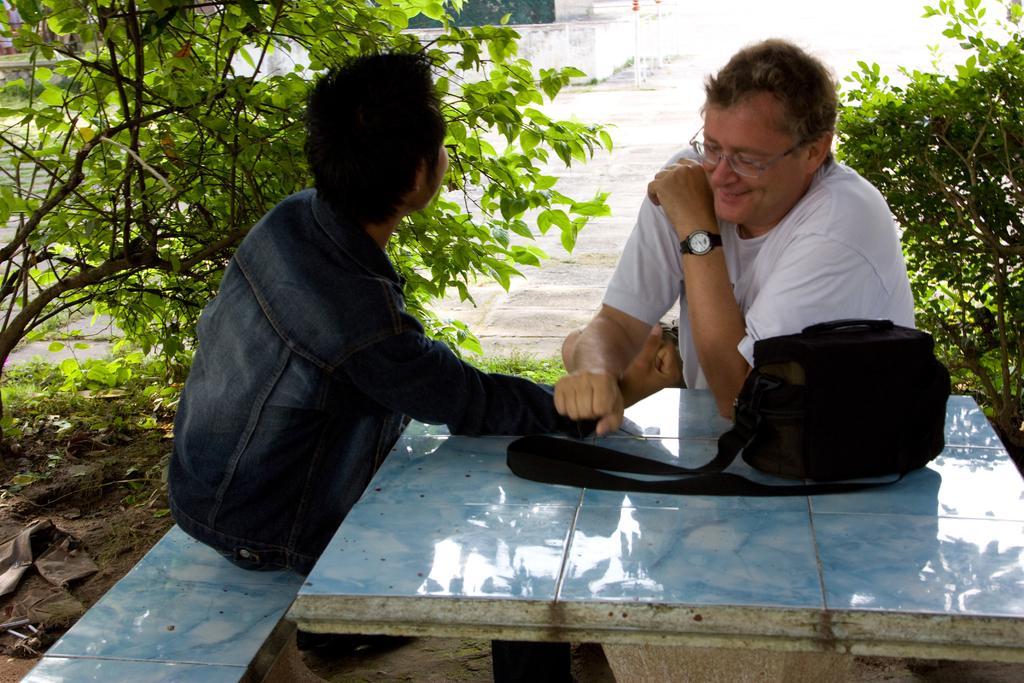Can you describe this image briefly? On the background we can see plants. We can see two men sitting here. And here on the table we can see a black colour bag. This man wore spectacles and watch. 